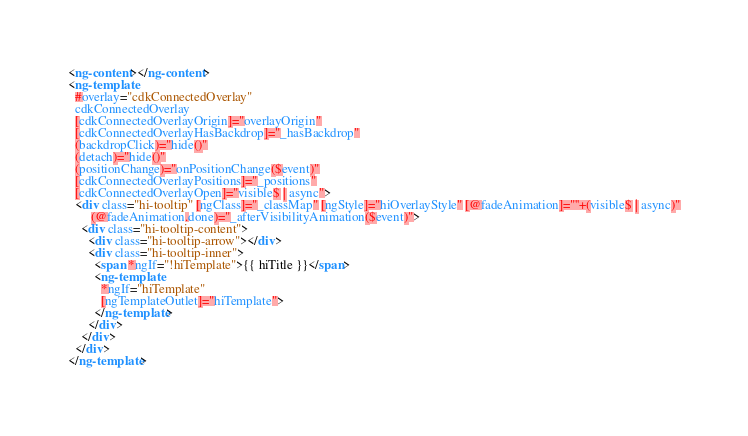<code> <loc_0><loc_0><loc_500><loc_500><_HTML_><ng-content></ng-content>
<ng-template
  #overlay="cdkConnectedOverlay"
  cdkConnectedOverlay
  [cdkConnectedOverlayOrigin]="overlayOrigin"
  [cdkConnectedOverlayHasBackdrop]="_hasBackdrop"
  (backdropClick)="hide()"
  (detach)="hide()"
  (positionChange)="onPositionChange($event)"
  [cdkConnectedOverlayPositions]="_positions"
  [cdkConnectedOverlayOpen]="visible$ | async">
  <div class="hi-tooltip" [ngClass]="_classMap" [ngStyle]="hiOverlayStyle" [@fadeAnimation]="''+(visible$ | async)"
       (@fadeAnimation.done)="_afterVisibilityAnimation($event)">
    <div class="hi-tooltip-content">
      <div class="hi-tooltip-arrow"></div>
      <div class="hi-tooltip-inner">
        <span *ngIf="!hiTemplate">{{ hiTitle }}</span>
        <ng-template
          *ngIf="hiTemplate"
          [ngTemplateOutlet]="hiTemplate">
        </ng-template>
      </div>
    </div>
  </div>
</ng-template>
</code> 